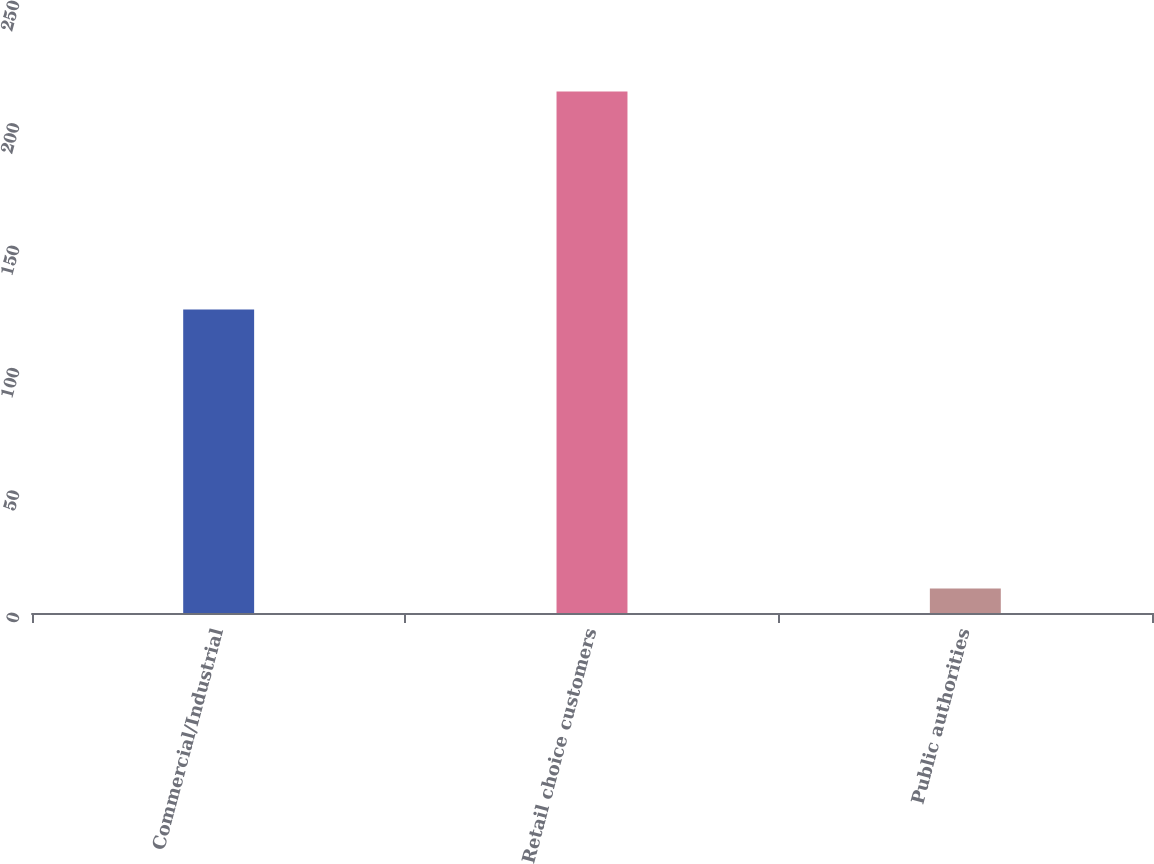Convert chart to OTSL. <chart><loc_0><loc_0><loc_500><loc_500><bar_chart><fcel>Commercial/Industrial<fcel>Retail choice customers<fcel>Public authorities<nl><fcel>124<fcel>213<fcel>10<nl></chart> 